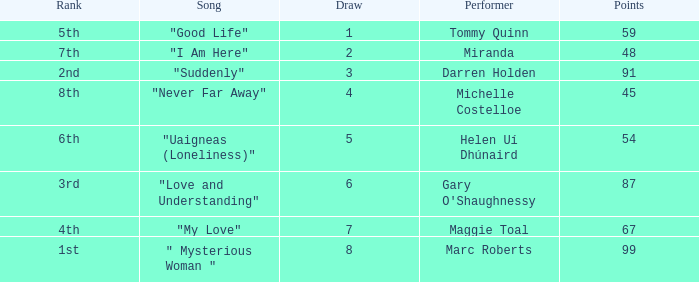What is the total number of draws for songs performed by Miranda with fewer than 48 points? 0.0. 